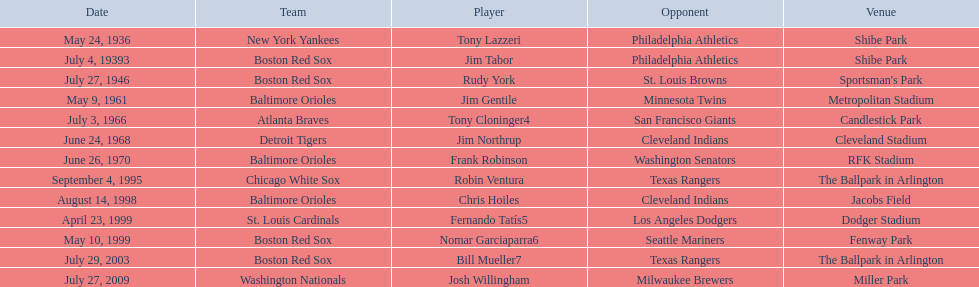What are the names of all the players? Tony Lazzeri, Jim Tabor, Rudy York, Jim Gentile, Tony Cloninger4, Jim Northrup, Frank Robinson, Robin Ventura, Chris Hoiles, Fernando Tatís5, Nomar Garciaparra6, Bill Mueller7, Josh Willingham. What are the names of all the teams holding home run records? New York Yankees, Boston Red Sox, Baltimore Orioles, Atlanta Braves, Detroit Tigers, Chicago White Sox, St. Louis Cardinals, Washington Nationals. Which player played for the new york yankees? Tony Lazzeri. 